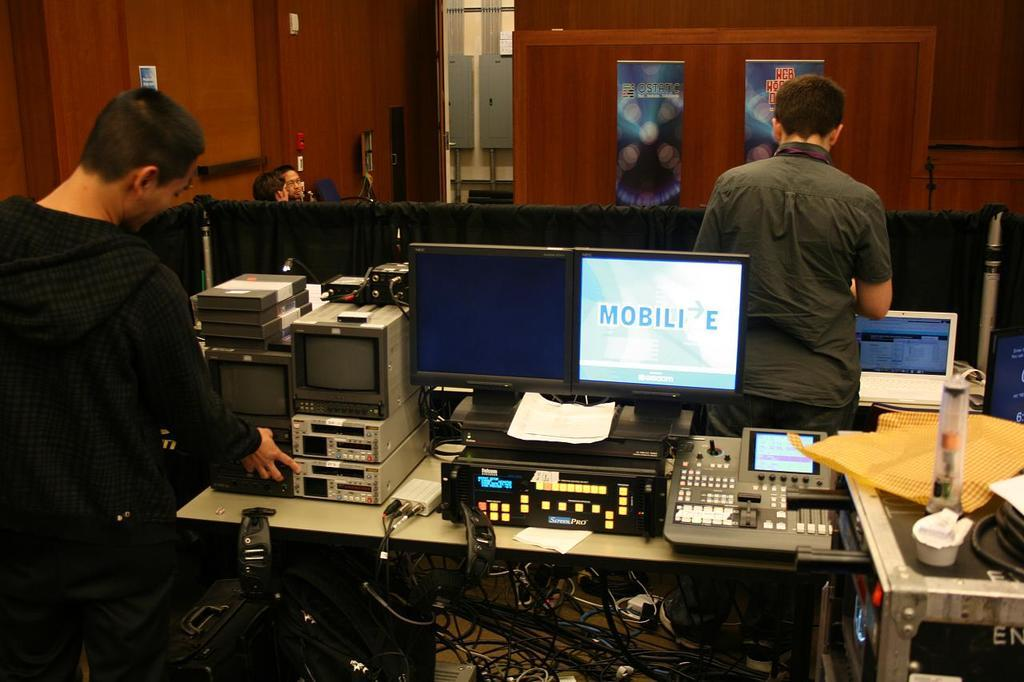<image>
Summarize the visual content of the image. Man working on a computer with a screen that says "Mobilie". 